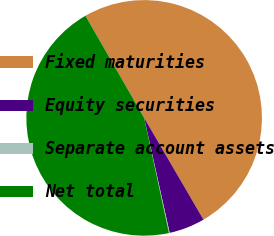Convert chart to OTSL. <chart><loc_0><loc_0><loc_500><loc_500><pie_chart><fcel>Fixed maturities<fcel>Equity securities<fcel>Separate account assets<fcel>Net total<nl><fcel>49.9%<fcel>4.93%<fcel>0.1%<fcel>45.07%<nl></chart> 